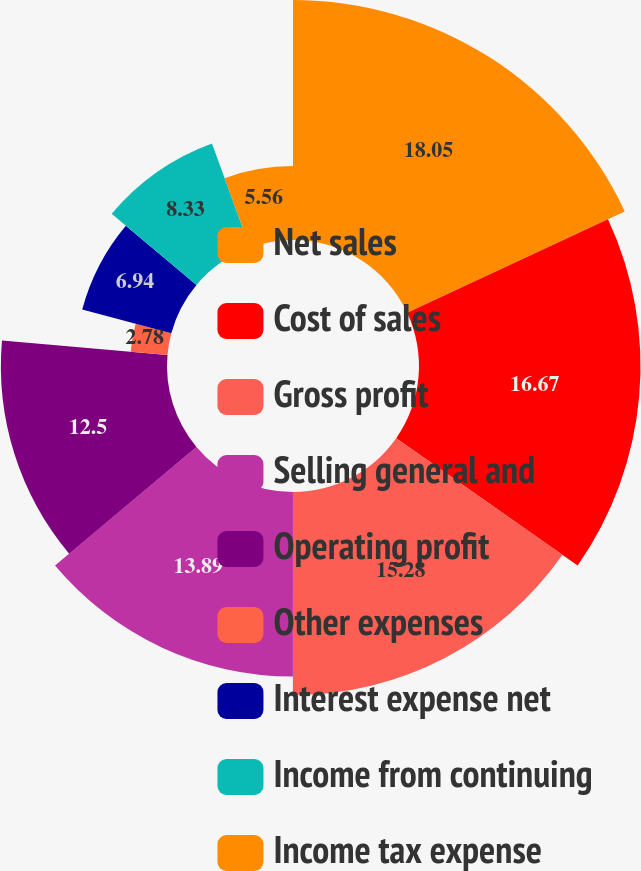Convert chart. <chart><loc_0><loc_0><loc_500><loc_500><pie_chart><fcel>Net sales<fcel>Cost of sales<fcel>Gross profit<fcel>Selling general and<fcel>Operating profit<fcel>Other expenses<fcel>Interest expense net<fcel>Income from continuing<fcel>Income tax expense<nl><fcel>18.06%<fcel>16.67%<fcel>15.28%<fcel>13.89%<fcel>12.5%<fcel>2.78%<fcel>6.94%<fcel>8.33%<fcel>5.56%<nl></chart> 